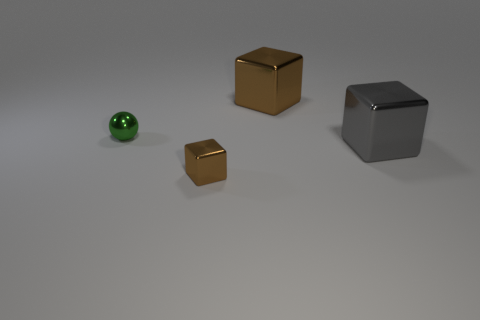How many other objects are there of the same color as the small ball?
Offer a very short reply. 0. What number of things are tiny brown metal things or cyan shiny blocks?
Keep it short and to the point. 1. There is a small metallic object that is in front of the gray shiny object; does it have the same shape as the gray shiny thing?
Offer a very short reply. Yes. What color is the big thing that is to the right of the brown metal block right of the small brown metallic object?
Keep it short and to the point. Gray. Are there fewer big objects than rubber cylinders?
Give a very brief answer. No. Is there a large gray object that has the same material as the tiny brown thing?
Ensure brevity in your answer.  Yes. Do the big gray metallic thing and the shiny thing in front of the large gray metal cube have the same shape?
Give a very brief answer. Yes. There is a tiny sphere; are there any large metal objects behind it?
Offer a very short reply. Yes. How many large objects are the same shape as the tiny green shiny object?
Your answer should be very brief. 0. How many small red matte objects are there?
Your answer should be compact. 0. 